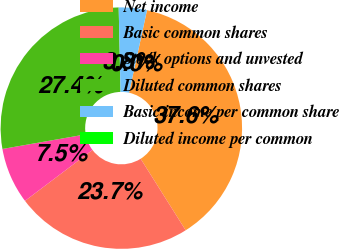<chart> <loc_0><loc_0><loc_500><loc_500><pie_chart><fcel>Net income<fcel>Basic common shares<fcel>Stock options and unvested<fcel>Diluted common shares<fcel>Basic income per common share<fcel>Diluted income per common<nl><fcel>37.64%<fcel>23.65%<fcel>7.53%<fcel>27.41%<fcel>3.76%<fcel>0.0%<nl></chart> 